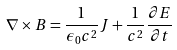Convert formula to latex. <formula><loc_0><loc_0><loc_500><loc_500>\nabla \times B = { \frac { 1 } { \epsilon _ { 0 } c ^ { 2 } } } J + { \frac { 1 } { c ^ { 2 } } } { \frac { \partial E } { \partial t } }</formula> 